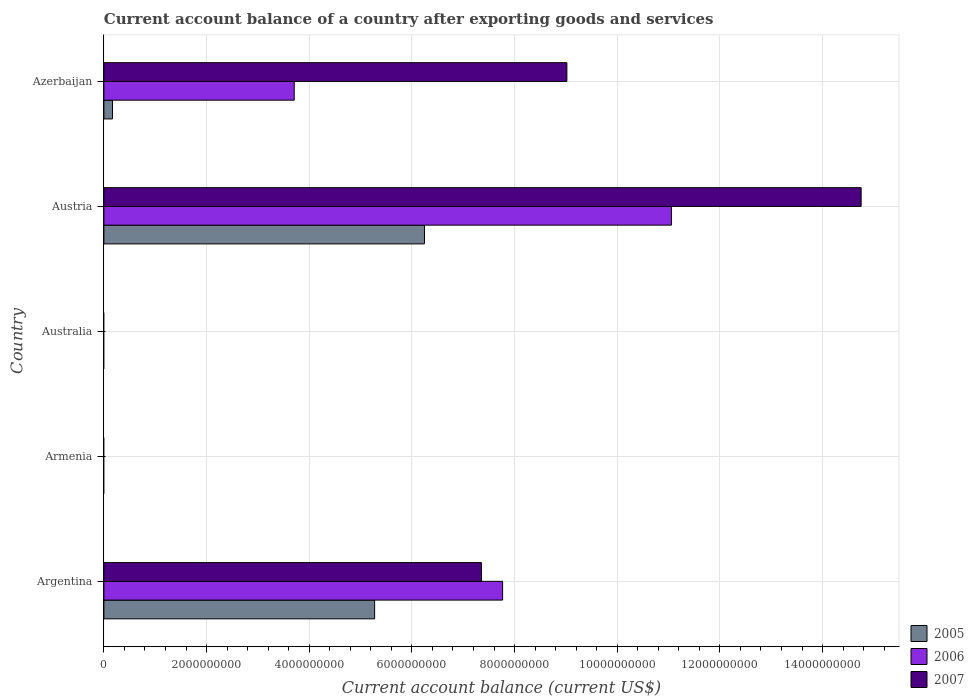Are the number of bars per tick equal to the number of legend labels?
Your answer should be very brief. No. How many bars are there on the 3rd tick from the top?
Offer a terse response. 0. What is the label of the 4th group of bars from the top?
Provide a short and direct response. Armenia. In how many cases, is the number of bars for a given country not equal to the number of legend labels?
Keep it short and to the point. 2. What is the account balance in 2007 in Austria?
Keep it short and to the point. 1.48e+1. Across all countries, what is the maximum account balance in 2005?
Make the answer very short. 6.25e+09. In which country was the account balance in 2007 maximum?
Offer a very short reply. Austria. What is the total account balance in 2006 in the graph?
Your answer should be compact. 2.25e+1. What is the difference between the account balance in 2006 in Argentina and that in Austria?
Offer a very short reply. -3.29e+09. What is the difference between the account balance in 2007 in Austria and the account balance in 2006 in Australia?
Your response must be concise. 1.48e+1. What is the average account balance in 2005 per country?
Your response must be concise. 2.34e+09. What is the difference between the account balance in 2007 and account balance in 2005 in Azerbaijan?
Keep it short and to the point. 8.85e+09. In how many countries, is the account balance in 2006 greater than 3200000000 US$?
Provide a succinct answer. 3. What is the ratio of the account balance in 2007 in Austria to that in Azerbaijan?
Your answer should be very brief. 1.64. Is the account balance in 2005 in Argentina less than that in Azerbaijan?
Your answer should be compact. No. Is the difference between the account balance in 2007 in Austria and Azerbaijan greater than the difference between the account balance in 2005 in Austria and Azerbaijan?
Ensure brevity in your answer.  No. What is the difference between the highest and the second highest account balance in 2007?
Provide a short and direct response. 5.73e+09. What is the difference between the highest and the lowest account balance in 2007?
Offer a terse response. 1.48e+1. In how many countries, is the account balance in 2005 greater than the average account balance in 2005 taken over all countries?
Make the answer very short. 2. Is it the case that in every country, the sum of the account balance in 2007 and account balance in 2006 is greater than the account balance in 2005?
Keep it short and to the point. No. How many countries are there in the graph?
Offer a very short reply. 5. Are the values on the major ticks of X-axis written in scientific E-notation?
Provide a succinct answer. No. Where does the legend appear in the graph?
Make the answer very short. Bottom right. What is the title of the graph?
Ensure brevity in your answer.  Current account balance of a country after exporting goods and services. Does "1993" appear as one of the legend labels in the graph?
Your answer should be very brief. No. What is the label or title of the X-axis?
Provide a short and direct response. Current account balance (current US$). What is the Current account balance (current US$) in 2005 in Argentina?
Provide a succinct answer. 5.27e+09. What is the Current account balance (current US$) of 2006 in Argentina?
Ensure brevity in your answer.  7.77e+09. What is the Current account balance (current US$) of 2007 in Argentina?
Provide a short and direct response. 7.35e+09. What is the Current account balance (current US$) in 2005 in Armenia?
Your response must be concise. 0. What is the Current account balance (current US$) of 2007 in Australia?
Provide a succinct answer. 0. What is the Current account balance (current US$) of 2005 in Austria?
Give a very brief answer. 6.25e+09. What is the Current account balance (current US$) in 2006 in Austria?
Give a very brief answer. 1.11e+1. What is the Current account balance (current US$) of 2007 in Austria?
Make the answer very short. 1.48e+1. What is the Current account balance (current US$) in 2005 in Azerbaijan?
Give a very brief answer. 1.67e+08. What is the Current account balance (current US$) in 2006 in Azerbaijan?
Make the answer very short. 3.71e+09. What is the Current account balance (current US$) of 2007 in Azerbaijan?
Ensure brevity in your answer.  9.02e+09. Across all countries, what is the maximum Current account balance (current US$) of 2005?
Offer a very short reply. 6.25e+09. Across all countries, what is the maximum Current account balance (current US$) in 2006?
Make the answer very short. 1.11e+1. Across all countries, what is the maximum Current account balance (current US$) of 2007?
Offer a terse response. 1.48e+1. Across all countries, what is the minimum Current account balance (current US$) in 2005?
Make the answer very short. 0. What is the total Current account balance (current US$) of 2005 in the graph?
Ensure brevity in your answer.  1.17e+1. What is the total Current account balance (current US$) in 2006 in the graph?
Offer a terse response. 2.25e+1. What is the total Current account balance (current US$) in 2007 in the graph?
Your answer should be compact. 3.11e+1. What is the difference between the Current account balance (current US$) of 2005 in Argentina and that in Austria?
Make the answer very short. -9.71e+08. What is the difference between the Current account balance (current US$) of 2006 in Argentina and that in Austria?
Offer a terse response. -3.29e+09. What is the difference between the Current account balance (current US$) of 2007 in Argentina and that in Austria?
Offer a terse response. -7.40e+09. What is the difference between the Current account balance (current US$) of 2005 in Argentina and that in Azerbaijan?
Provide a succinct answer. 5.11e+09. What is the difference between the Current account balance (current US$) in 2006 in Argentina and that in Azerbaijan?
Ensure brevity in your answer.  4.06e+09. What is the difference between the Current account balance (current US$) in 2007 in Argentina and that in Azerbaijan?
Provide a short and direct response. -1.66e+09. What is the difference between the Current account balance (current US$) in 2005 in Austria and that in Azerbaijan?
Provide a short and direct response. 6.08e+09. What is the difference between the Current account balance (current US$) in 2006 in Austria and that in Azerbaijan?
Your answer should be very brief. 7.35e+09. What is the difference between the Current account balance (current US$) in 2007 in Austria and that in Azerbaijan?
Give a very brief answer. 5.73e+09. What is the difference between the Current account balance (current US$) in 2005 in Argentina and the Current account balance (current US$) in 2006 in Austria?
Keep it short and to the point. -5.78e+09. What is the difference between the Current account balance (current US$) in 2005 in Argentina and the Current account balance (current US$) in 2007 in Austria?
Provide a short and direct response. -9.48e+09. What is the difference between the Current account balance (current US$) of 2006 in Argentina and the Current account balance (current US$) of 2007 in Austria?
Provide a succinct answer. -6.98e+09. What is the difference between the Current account balance (current US$) of 2005 in Argentina and the Current account balance (current US$) of 2006 in Azerbaijan?
Give a very brief answer. 1.57e+09. What is the difference between the Current account balance (current US$) in 2005 in Argentina and the Current account balance (current US$) in 2007 in Azerbaijan?
Provide a short and direct response. -3.75e+09. What is the difference between the Current account balance (current US$) of 2006 in Argentina and the Current account balance (current US$) of 2007 in Azerbaijan?
Offer a terse response. -1.25e+09. What is the difference between the Current account balance (current US$) in 2005 in Austria and the Current account balance (current US$) in 2006 in Azerbaijan?
Your answer should be compact. 2.54e+09. What is the difference between the Current account balance (current US$) in 2005 in Austria and the Current account balance (current US$) in 2007 in Azerbaijan?
Provide a succinct answer. -2.77e+09. What is the difference between the Current account balance (current US$) of 2006 in Austria and the Current account balance (current US$) of 2007 in Azerbaijan?
Provide a short and direct response. 2.04e+09. What is the average Current account balance (current US$) of 2005 per country?
Provide a short and direct response. 2.34e+09. What is the average Current account balance (current US$) in 2006 per country?
Make the answer very short. 4.51e+09. What is the average Current account balance (current US$) of 2007 per country?
Offer a very short reply. 6.22e+09. What is the difference between the Current account balance (current US$) of 2005 and Current account balance (current US$) of 2006 in Argentina?
Offer a terse response. -2.49e+09. What is the difference between the Current account balance (current US$) in 2005 and Current account balance (current US$) in 2007 in Argentina?
Your answer should be very brief. -2.08e+09. What is the difference between the Current account balance (current US$) of 2006 and Current account balance (current US$) of 2007 in Argentina?
Give a very brief answer. 4.13e+08. What is the difference between the Current account balance (current US$) of 2005 and Current account balance (current US$) of 2006 in Austria?
Your answer should be compact. -4.81e+09. What is the difference between the Current account balance (current US$) in 2005 and Current account balance (current US$) in 2007 in Austria?
Your answer should be very brief. -8.51e+09. What is the difference between the Current account balance (current US$) of 2006 and Current account balance (current US$) of 2007 in Austria?
Your response must be concise. -3.70e+09. What is the difference between the Current account balance (current US$) in 2005 and Current account balance (current US$) in 2006 in Azerbaijan?
Provide a short and direct response. -3.54e+09. What is the difference between the Current account balance (current US$) in 2005 and Current account balance (current US$) in 2007 in Azerbaijan?
Your answer should be compact. -8.85e+09. What is the difference between the Current account balance (current US$) in 2006 and Current account balance (current US$) in 2007 in Azerbaijan?
Your response must be concise. -5.31e+09. What is the ratio of the Current account balance (current US$) in 2005 in Argentina to that in Austria?
Offer a very short reply. 0.84. What is the ratio of the Current account balance (current US$) in 2006 in Argentina to that in Austria?
Make the answer very short. 0.7. What is the ratio of the Current account balance (current US$) of 2007 in Argentina to that in Austria?
Provide a succinct answer. 0.5. What is the ratio of the Current account balance (current US$) of 2005 in Argentina to that in Azerbaijan?
Your response must be concise. 31.52. What is the ratio of the Current account balance (current US$) of 2006 in Argentina to that in Azerbaijan?
Your response must be concise. 2.09. What is the ratio of the Current account balance (current US$) in 2007 in Argentina to that in Azerbaijan?
Make the answer very short. 0.82. What is the ratio of the Current account balance (current US$) of 2005 in Austria to that in Azerbaijan?
Offer a very short reply. 37.33. What is the ratio of the Current account balance (current US$) in 2006 in Austria to that in Azerbaijan?
Your response must be concise. 2.98. What is the ratio of the Current account balance (current US$) of 2007 in Austria to that in Azerbaijan?
Your response must be concise. 1.64. What is the difference between the highest and the second highest Current account balance (current US$) of 2005?
Give a very brief answer. 9.71e+08. What is the difference between the highest and the second highest Current account balance (current US$) of 2006?
Make the answer very short. 3.29e+09. What is the difference between the highest and the second highest Current account balance (current US$) in 2007?
Offer a very short reply. 5.73e+09. What is the difference between the highest and the lowest Current account balance (current US$) of 2005?
Ensure brevity in your answer.  6.25e+09. What is the difference between the highest and the lowest Current account balance (current US$) in 2006?
Offer a very short reply. 1.11e+1. What is the difference between the highest and the lowest Current account balance (current US$) in 2007?
Offer a terse response. 1.48e+1. 